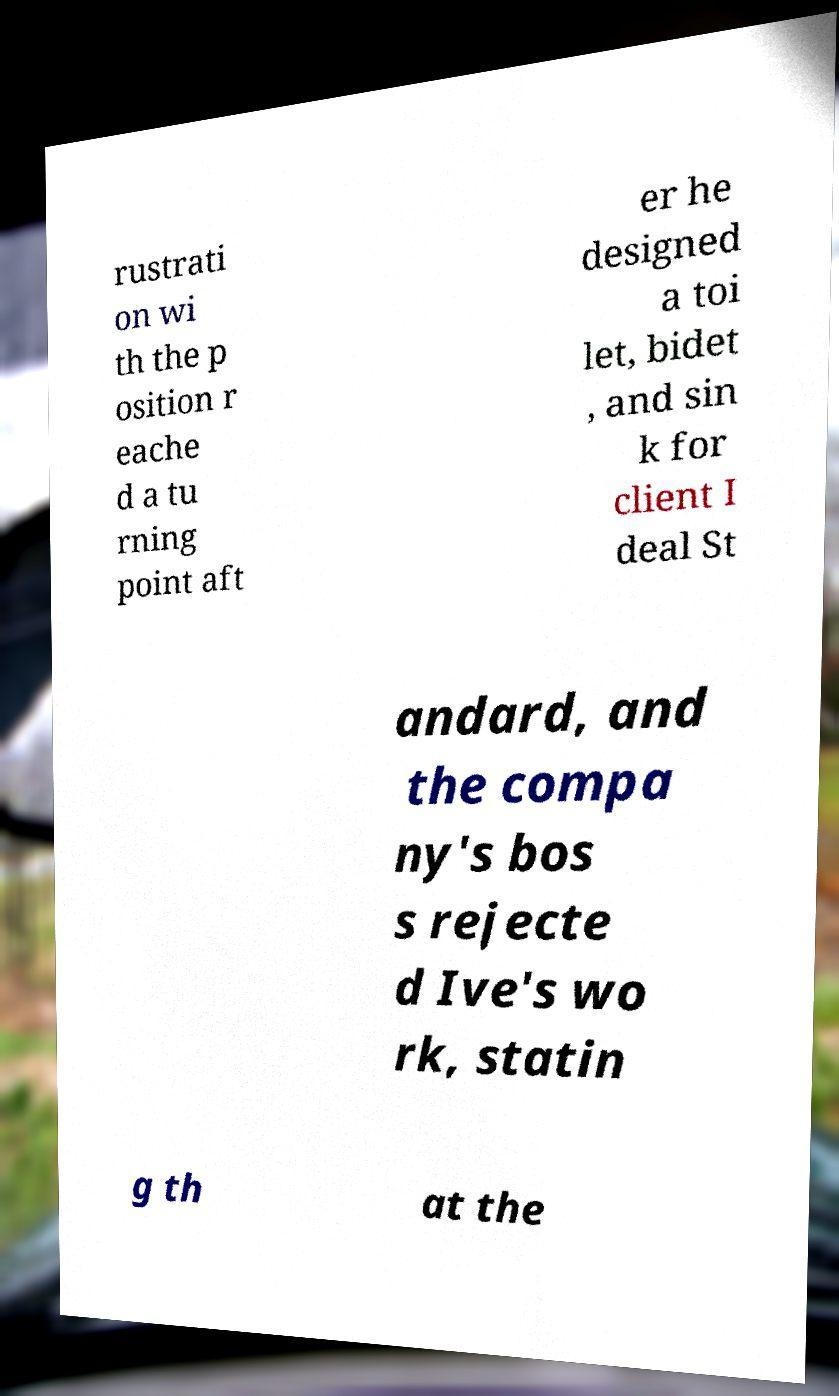Can you read and provide the text displayed in the image?This photo seems to have some interesting text. Can you extract and type it out for me? rustrati on wi th the p osition r eache d a tu rning point aft er he designed a toi let, bidet , and sin k for client I deal St andard, and the compa ny's bos s rejecte d Ive's wo rk, statin g th at the 